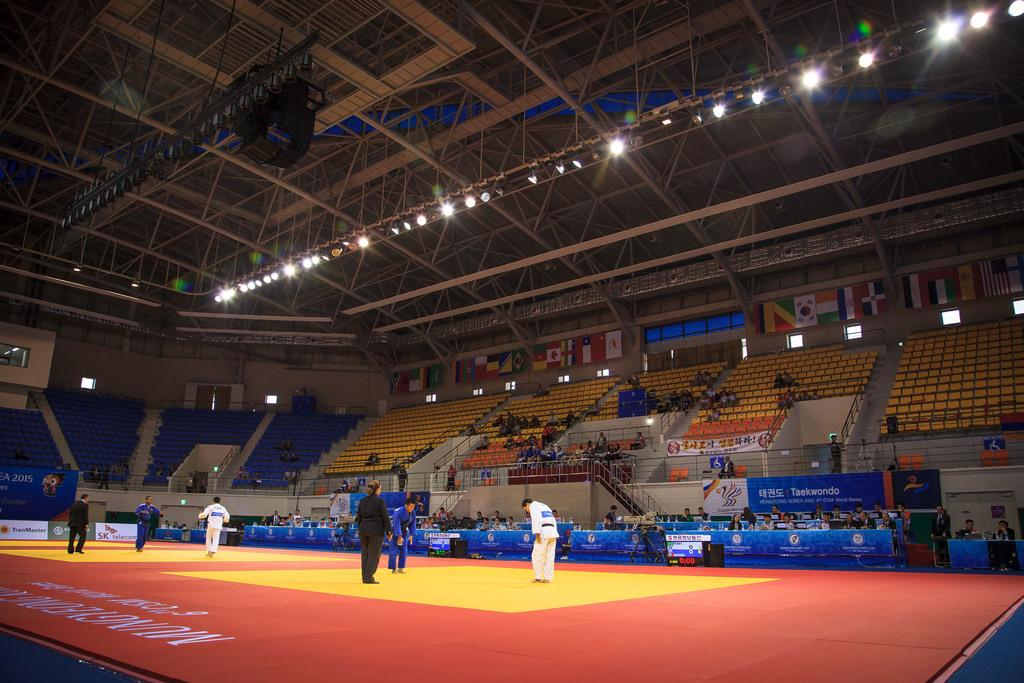<image>
Share a concise interpretation of the image provided. People are competing in an arena in a Taekwondo match. 